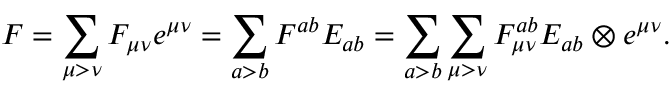Convert formula to latex. <formula><loc_0><loc_0><loc_500><loc_500>F = \sum _ { \mu > \nu } F _ { \mu \nu } e ^ { \mu \nu } = \sum _ { a > b } F ^ { a b } E _ { a b } = \sum _ { a > b } \sum _ { \mu > \nu } F _ { \mu \nu } ^ { a b } E _ { a b } \otimes e ^ { \mu \nu } .</formula> 